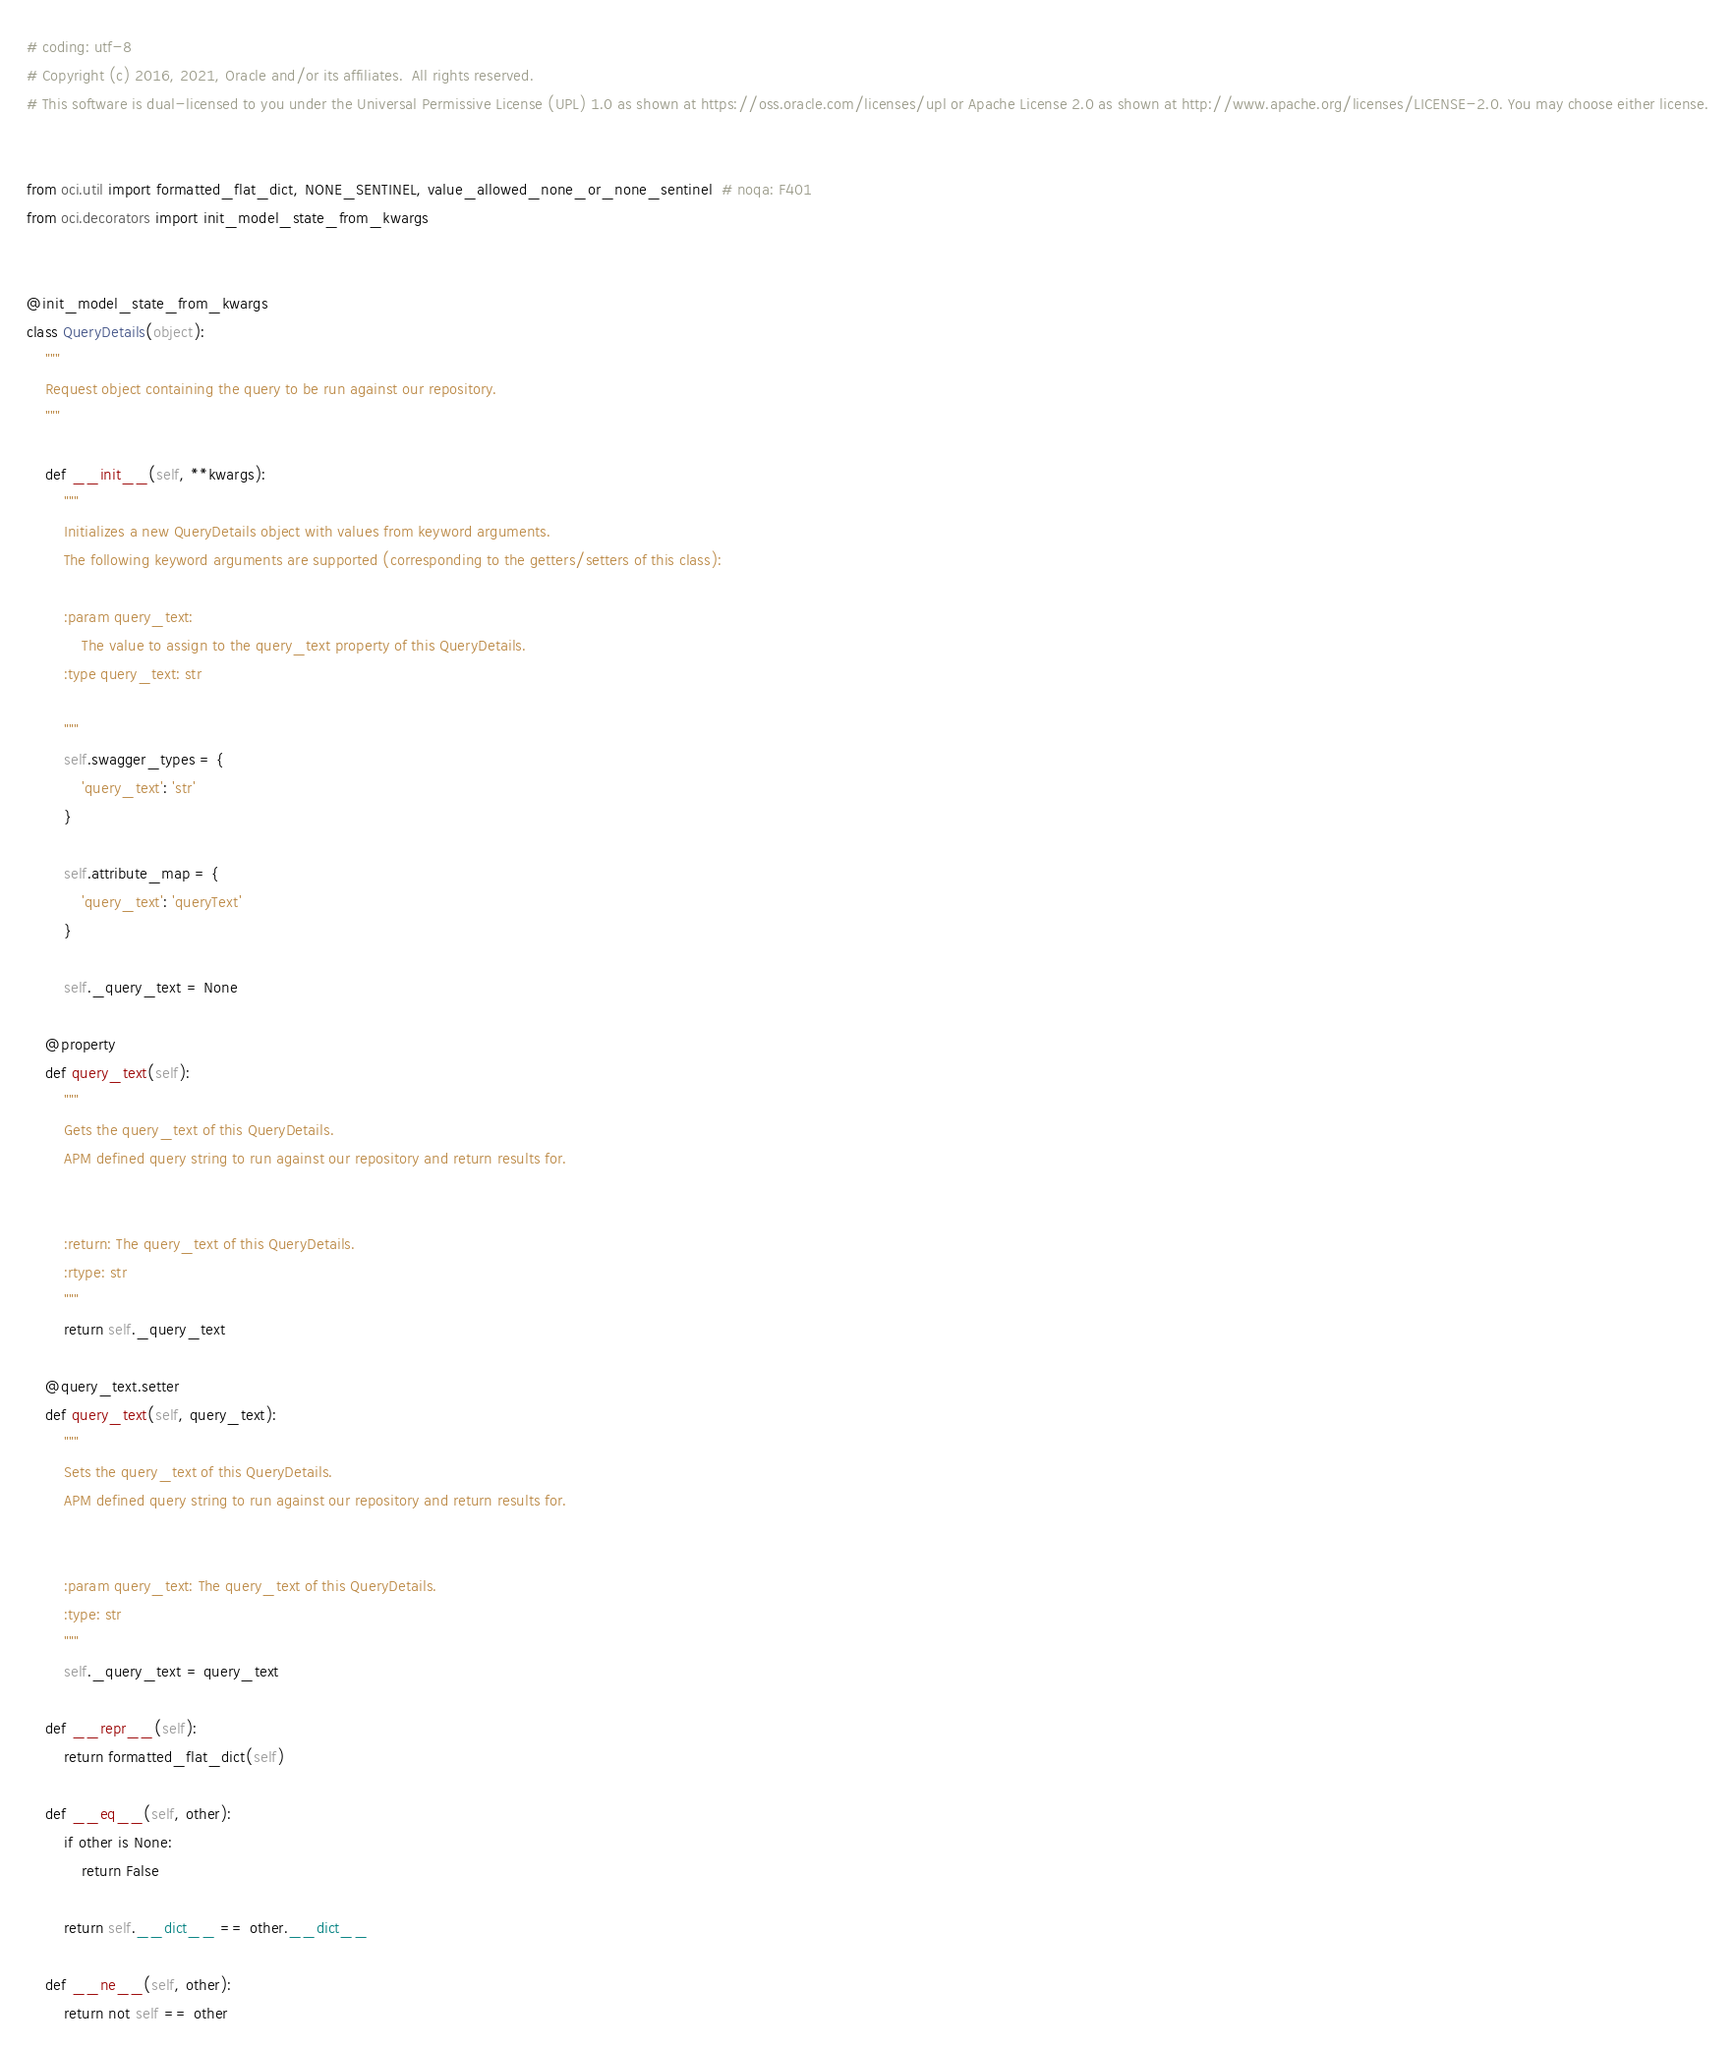Convert code to text. <code><loc_0><loc_0><loc_500><loc_500><_Python_># coding: utf-8
# Copyright (c) 2016, 2021, Oracle and/or its affiliates.  All rights reserved.
# This software is dual-licensed to you under the Universal Permissive License (UPL) 1.0 as shown at https://oss.oracle.com/licenses/upl or Apache License 2.0 as shown at http://www.apache.org/licenses/LICENSE-2.0. You may choose either license.


from oci.util import formatted_flat_dict, NONE_SENTINEL, value_allowed_none_or_none_sentinel  # noqa: F401
from oci.decorators import init_model_state_from_kwargs


@init_model_state_from_kwargs
class QueryDetails(object):
    """
    Request object containing the query to be run against our repository.
    """

    def __init__(self, **kwargs):
        """
        Initializes a new QueryDetails object with values from keyword arguments.
        The following keyword arguments are supported (corresponding to the getters/setters of this class):

        :param query_text:
            The value to assign to the query_text property of this QueryDetails.
        :type query_text: str

        """
        self.swagger_types = {
            'query_text': 'str'
        }

        self.attribute_map = {
            'query_text': 'queryText'
        }

        self._query_text = None

    @property
    def query_text(self):
        """
        Gets the query_text of this QueryDetails.
        APM defined query string to run against our repository and return results for.


        :return: The query_text of this QueryDetails.
        :rtype: str
        """
        return self._query_text

    @query_text.setter
    def query_text(self, query_text):
        """
        Sets the query_text of this QueryDetails.
        APM defined query string to run against our repository and return results for.


        :param query_text: The query_text of this QueryDetails.
        :type: str
        """
        self._query_text = query_text

    def __repr__(self):
        return formatted_flat_dict(self)

    def __eq__(self, other):
        if other is None:
            return False

        return self.__dict__ == other.__dict__

    def __ne__(self, other):
        return not self == other
</code> 